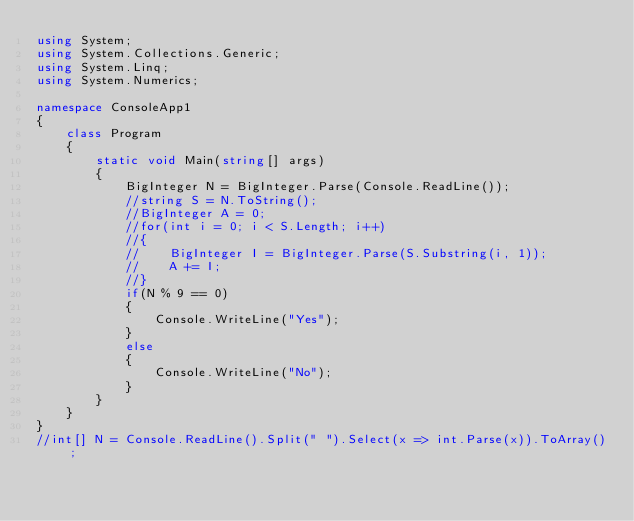Convert code to text. <code><loc_0><loc_0><loc_500><loc_500><_C#_>using System;
using System.Collections.Generic;
using System.Linq;
using System.Numerics;

namespace ConsoleApp1
{
    class Program
    {
        static void Main(string[] args)
        {
            BigInteger N = BigInteger.Parse(Console.ReadLine());
            //string S = N.ToString();
            //BigInteger A = 0;
            //for(int i = 0; i < S.Length; i++)
            //{
            //    BigInteger I = BigInteger.Parse(S.Substring(i, 1));
            //    A += I;
            //}
            if(N % 9 == 0)
            {
                Console.WriteLine("Yes");
            }
            else
            {
                Console.WriteLine("No");
            }
        }
    }
}
//int[] N = Console.ReadLine().Split(" ").Select(x => int.Parse(x)).ToArray();</code> 